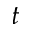Convert formula to latex. <formula><loc_0><loc_0><loc_500><loc_500>t</formula> 